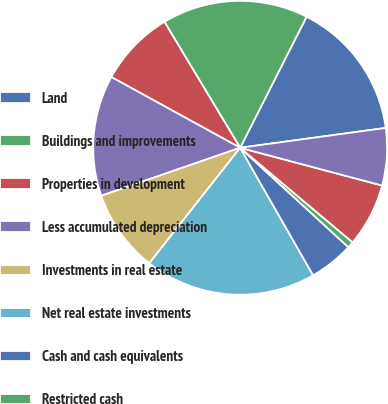<chart> <loc_0><loc_0><loc_500><loc_500><pie_chart><fcel>Land<fcel>Buildings and improvements<fcel>Properties in development<fcel>Less accumulated depreciation<fcel>Investments in real estate<fcel>Net real estate investments<fcel>Cash and cash equivalents<fcel>Restricted cash<fcel>Tenant and other receivables<fcel>Deferred leasing costs less<nl><fcel>15.38%<fcel>16.08%<fcel>8.39%<fcel>13.29%<fcel>9.09%<fcel>18.88%<fcel>4.9%<fcel>0.7%<fcel>6.99%<fcel>6.29%<nl></chart> 